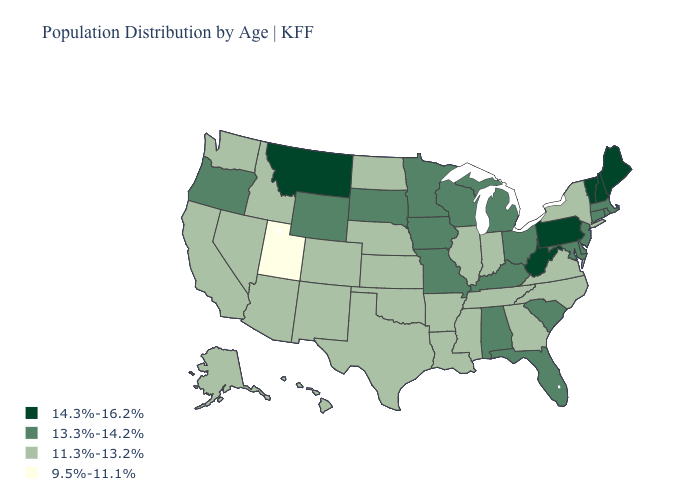What is the lowest value in the USA?
Short answer required. 9.5%-11.1%. Among the states that border New York , does Vermont have the lowest value?
Quick response, please. No. Name the states that have a value in the range 13.3%-14.2%?
Write a very short answer. Alabama, Connecticut, Delaware, Florida, Iowa, Kentucky, Maryland, Massachusetts, Michigan, Minnesota, Missouri, New Jersey, Ohio, Oregon, Rhode Island, South Carolina, South Dakota, Wisconsin, Wyoming. Which states hav the highest value in the MidWest?
Answer briefly. Iowa, Michigan, Minnesota, Missouri, Ohio, South Dakota, Wisconsin. What is the lowest value in states that border Montana?
Answer briefly. 11.3%-13.2%. What is the highest value in the MidWest ?
Quick response, please. 13.3%-14.2%. Does the map have missing data?
Concise answer only. No. What is the value of Colorado?
Quick response, please. 11.3%-13.2%. What is the value of Missouri?
Write a very short answer. 13.3%-14.2%. Does Minnesota have the same value as Florida?
Short answer required. Yes. Name the states that have a value in the range 9.5%-11.1%?
Short answer required. Utah. What is the highest value in the USA?
Be succinct. 14.3%-16.2%. What is the highest value in states that border Ohio?
Concise answer only. 14.3%-16.2%. Among the states that border Maine , which have the highest value?
Quick response, please. New Hampshire. What is the lowest value in states that border Colorado?
Be succinct. 9.5%-11.1%. 